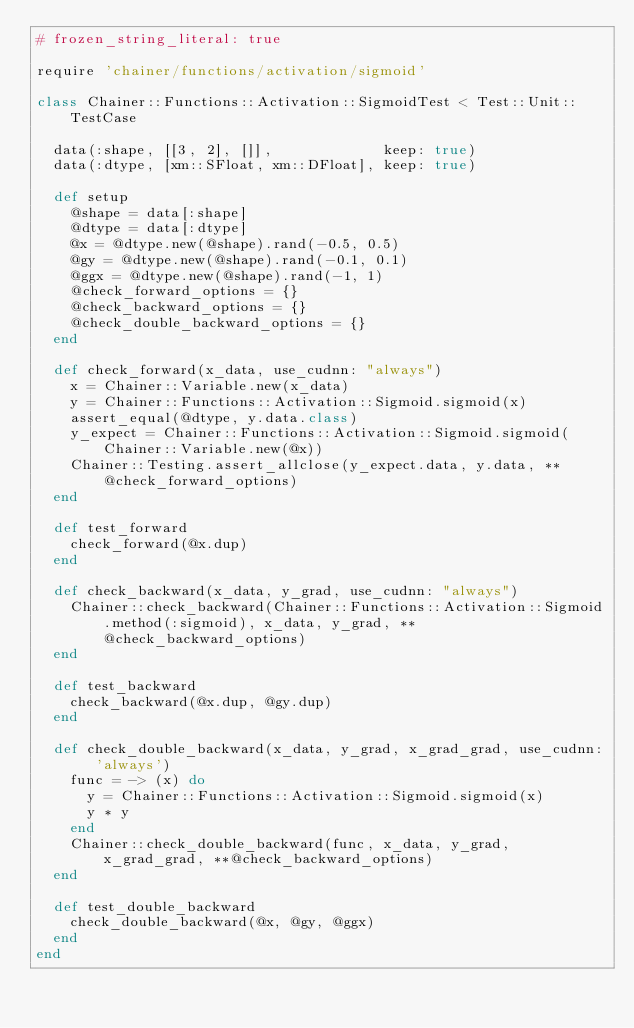Convert code to text. <code><loc_0><loc_0><loc_500><loc_500><_Ruby_># frozen_string_literal: true

require 'chainer/functions/activation/sigmoid'

class Chainer::Functions::Activation::SigmoidTest < Test::Unit::TestCase

  data(:shape, [[3, 2], []],             keep: true)
  data(:dtype, [xm::SFloat, xm::DFloat], keep: true)

  def setup
    @shape = data[:shape]
    @dtype = data[:dtype]
    @x = @dtype.new(@shape).rand(-0.5, 0.5)
    @gy = @dtype.new(@shape).rand(-0.1, 0.1)
    @ggx = @dtype.new(@shape).rand(-1, 1)
    @check_forward_options = {}
    @check_backward_options = {}
    @check_double_backward_options = {}
  end

  def check_forward(x_data, use_cudnn: "always")
    x = Chainer::Variable.new(x_data)
    y = Chainer::Functions::Activation::Sigmoid.sigmoid(x)
    assert_equal(@dtype, y.data.class)
    y_expect = Chainer::Functions::Activation::Sigmoid.sigmoid(Chainer::Variable.new(@x))
    Chainer::Testing.assert_allclose(y_expect.data, y.data, **@check_forward_options)
  end

  def test_forward
    check_forward(@x.dup)
  end

  def check_backward(x_data, y_grad, use_cudnn: "always")
    Chainer::check_backward(Chainer::Functions::Activation::Sigmoid.method(:sigmoid), x_data, y_grad, **@check_backward_options)
  end

  def test_backward
    check_backward(@x.dup, @gy.dup)
  end

  def check_double_backward(x_data, y_grad, x_grad_grad, use_cudnn: 'always')
    func = -> (x) do
      y = Chainer::Functions::Activation::Sigmoid.sigmoid(x)
      y * y
    end
    Chainer::check_double_backward(func, x_data, y_grad, x_grad_grad, **@check_backward_options)
  end

  def test_double_backward
    check_double_backward(@x, @gy, @ggx)
  end
end
</code> 